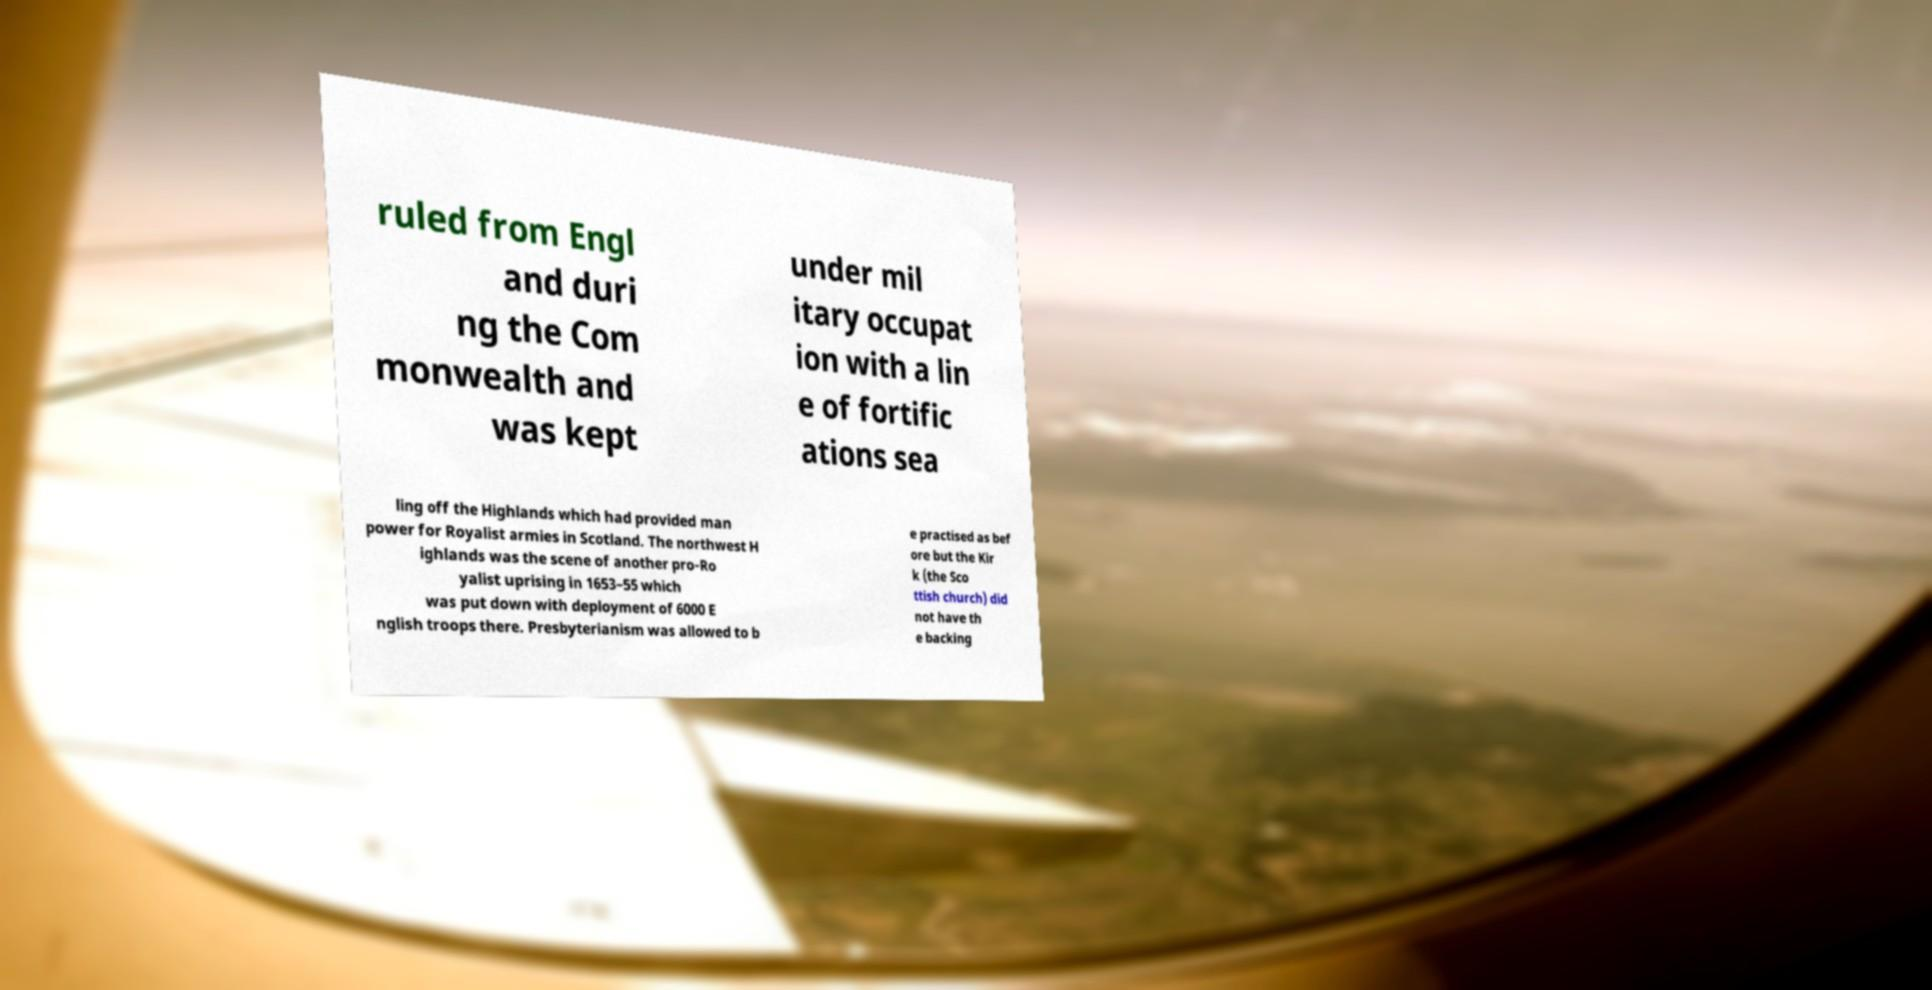Please read and relay the text visible in this image. What does it say? ruled from Engl and duri ng the Com monwealth and was kept under mil itary occupat ion with a lin e of fortific ations sea ling off the Highlands which had provided man power for Royalist armies in Scotland. The northwest H ighlands was the scene of another pro-Ro yalist uprising in 1653–55 which was put down with deployment of 6000 E nglish troops there. Presbyterianism was allowed to b e practised as bef ore but the Kir k (the Sco ttish church) did not have th e backing 